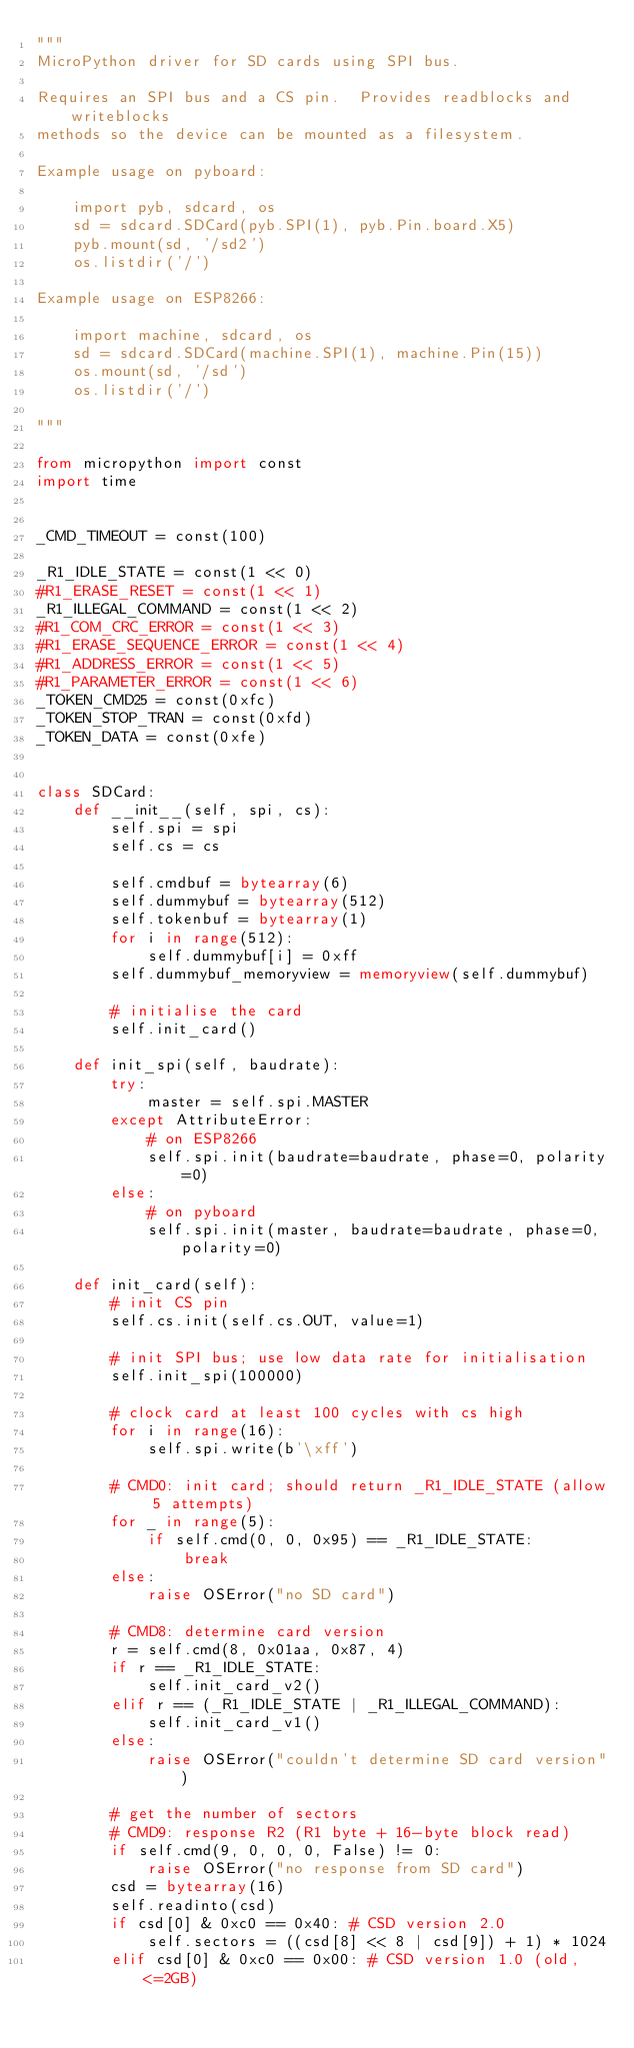Convert code to text. <code><loc_0><loc_0><loc_500><loc_500><_Python_>"""
MicroPython driver for SD cards using SPI bus.

Requires an SPI bus and a CS pin.  Provides readblocks and writeblocks
methods so the device can be mounted as a filesystem.

Example usage on pyboard:

    import pyb, sdcard, os
    sd = sdcard.SDCard(pyb.SPI(1), pyb.Pin.board.X5)
    pyb.mount(sd, '/sd2')
    os.listdir('/')

Example usage on ESP8266:

    import machine, sdcard, os
    sd = sdcard.SDCard(machine.SPI(1), machine.Pin(15))
    os.mount(sd, '/sd')
    os.listdir('/')

"""

from micropython import const
import time


_CMD_TIMEOUT = const(100)

_R1_IDLE_STATE = const(1 << 0)
#R1_ERASE_RESET = const(1 << 1)
_R1_ILLEGAL_COMMAND = const(1 << 2)
#R1_COM_CRC_ERROR = const(1 << 3)
#R1_ERASE_SEQUENCE_ERROR = const(1 << 4)
#R1_ADDRESS_ERROR = const(1 << 5)
#R1_PARAMETER_ERROR = const(1 << 6)
_TOKEN_CMD25 = const(0xfc)
_TOKEN_STOP_TRAN = const(0xfd)
_TOKEN_DATA = const(0xfe)


class SDCard:
    def __init__(self, spi, cs):
        self.spi = spi
        self.cs = cs

        self.cmdbuf = bytearray(6)
        self.dummybuf = bytearray(512)
        self.tokenbuf = bytearray(1)
        for i in range(512):
            self.dummybuf[i] = 0xff
        self.dummybuf_memoryview = memoryview(self.dummybuf)

        # initialise the card
        self.init_card()

    def init_spi(self, baudrate):
        try:
            master = self.spi.MASTER
        except AttributeError:
            # on ESP8266
            self.spi.init(baudrate=baudrate, phase=0, polarity=0)
        else:
            # on pyboard
            self.spi.init(master, baudrate=baudrate, phase=0, polarity=0)

    def init_card(self):
        # init CS pin
        self.cs.init(self.cs.OUT, value=1)

        # init SPI bus; use low data rate for initialisation
        self.init_spi(100000)

        # clock card at least 100 cycles with cs high
        for i in range(16):
            self.spi.write(b'\xff')

        # CMD0: init card; should return _R1_IDLE_STATE (allow 5 attempts)
        for _ in range(5):
            if self.cmd(0, 0, 0x95) == _R1_IDLE_STATE:
                break
        else:
            raise OSError("no SD card")

        # CMD8: determine card version
        r = self.cmd(8, 0x01aa, 0x87, 4)
        if r == _R1_IDLE_STATE:
            self.init_card_v2()
        elif r == (_R1_IDLE_STATE | _R1_ILLEGAL_COMMAND):
            self.init_card_v1()
        else:
            raise OSError("couldn't determine SD card version")

        # get the number of sectors
        # CMD9: response R2 (R1 byte + 16-byte block read)
        if self.cmd(9, 0, 0, 0, False) != 0:
            raise OSError("no response from SD card")
        csd = bytearray(16)
        self.readinto(csd)
        if csd[0] & 0xc0 == 0x40: # CSD version 2.0
            self.sectors = ((csd[8] << 8 | csd[9]) + 1) * 1024
        elif csd[0] & 0xc0 == 0x00: # CSD version 1.0 (old, <=2GB)</code> 